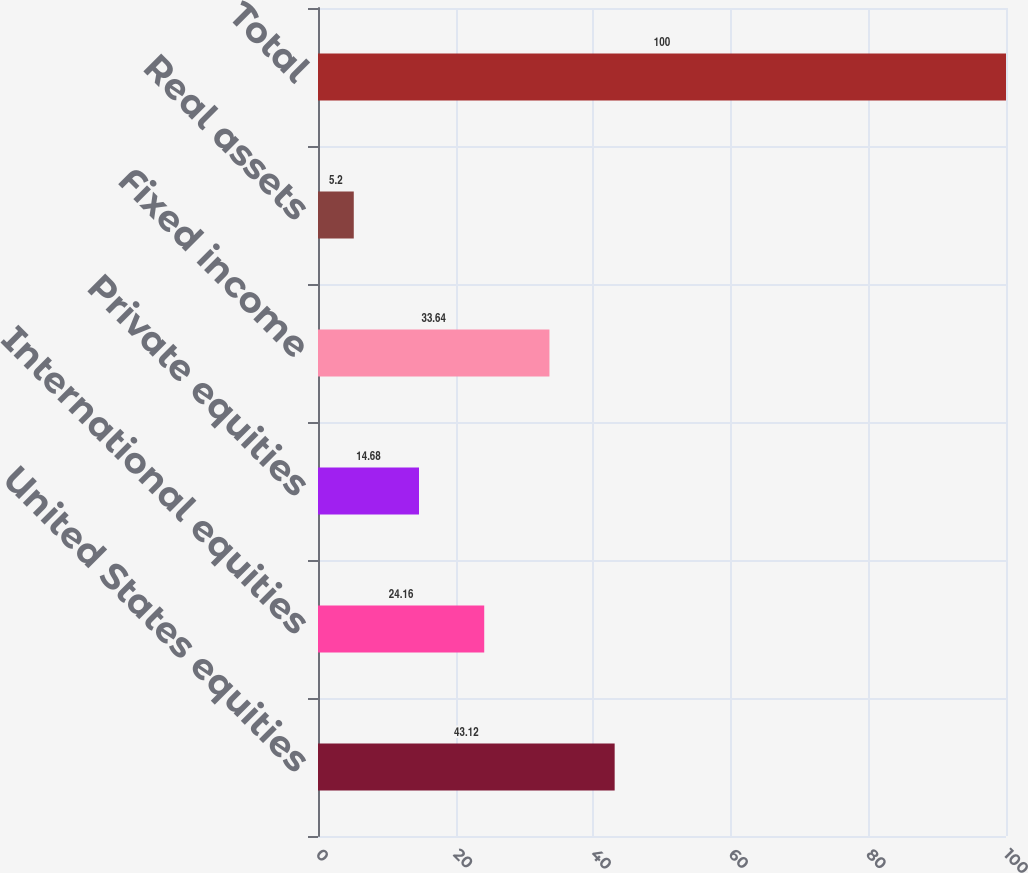<chart> <loc_0><loc_0><loc_500><loc_500><bar_chart><fcel>United States equities<fcel>International equities<fcel>Private equities<fcel>Fixed income<fcel>Real assets<fcel>Total<nl><fcel>43.12<fcel>24.16<fcel>14.68<fcel>33.64<fcel>5.2<fcel>100<nl></chart> 